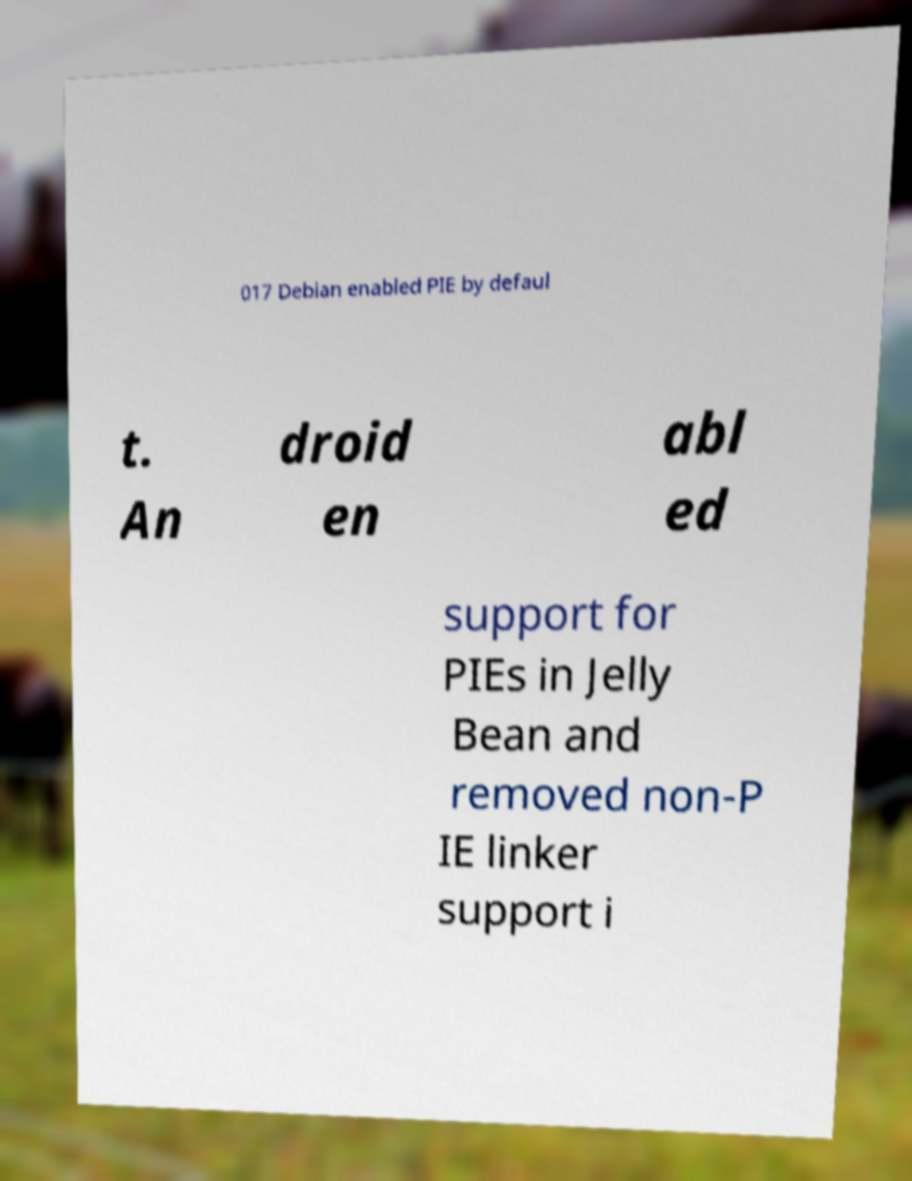Please read and relay the text visible in this image. What does it say? 017 Debian enabled PIE by defaul t. An droid en abl ed support for PIEs in Jelly Bean and removed non-P IE linker support i 